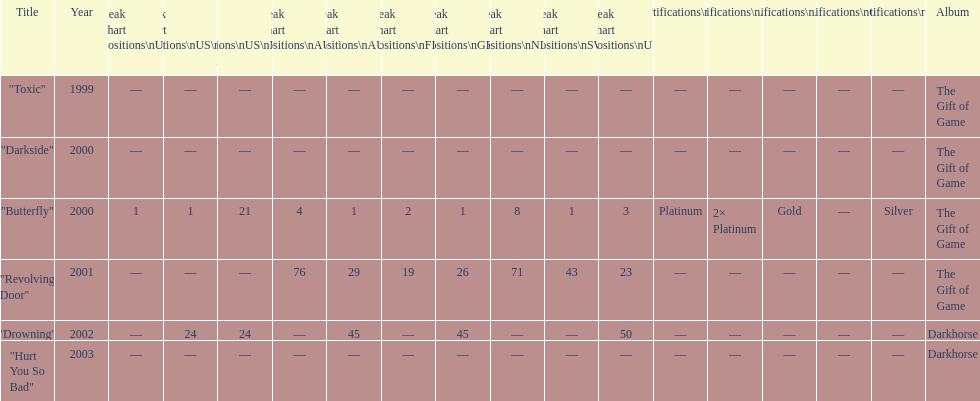Which single ranks 1 in us and 1 in us alt? "Butterfly". 